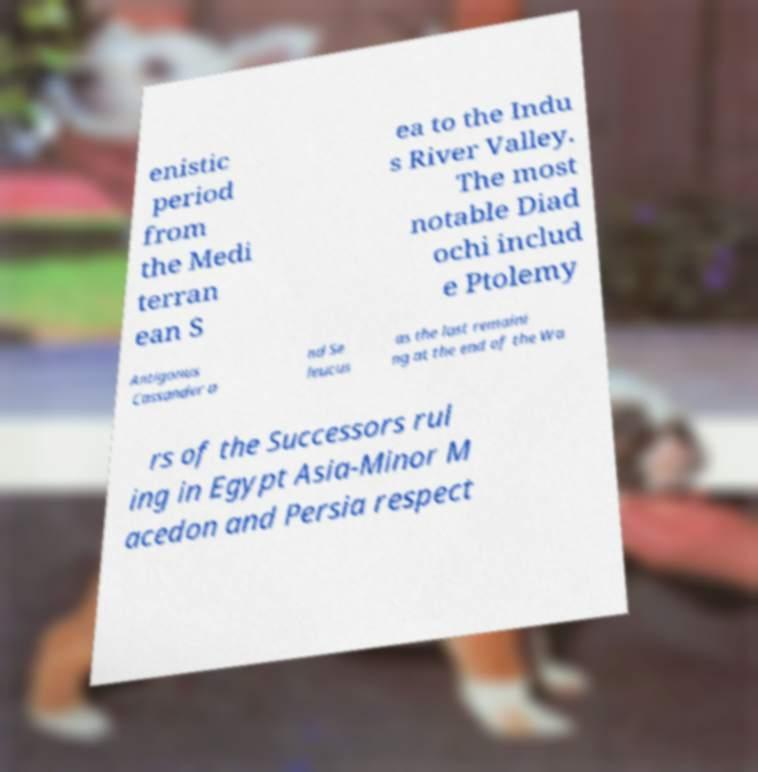Can you read and provide the text displayed in the image?This photo seems to have some interesting text. Can you extract and type it out for me? enistic period from the Medi terran ean S ea to the Indu s River Valley. The most notable Diad ochi includ e Ptolemy Antigonus Cassander a nd Se leucus as the last remaini ng at the end of the Wa rs of the Successors rul ing in Egypt Asia-Minor M acedon and Persia respect 